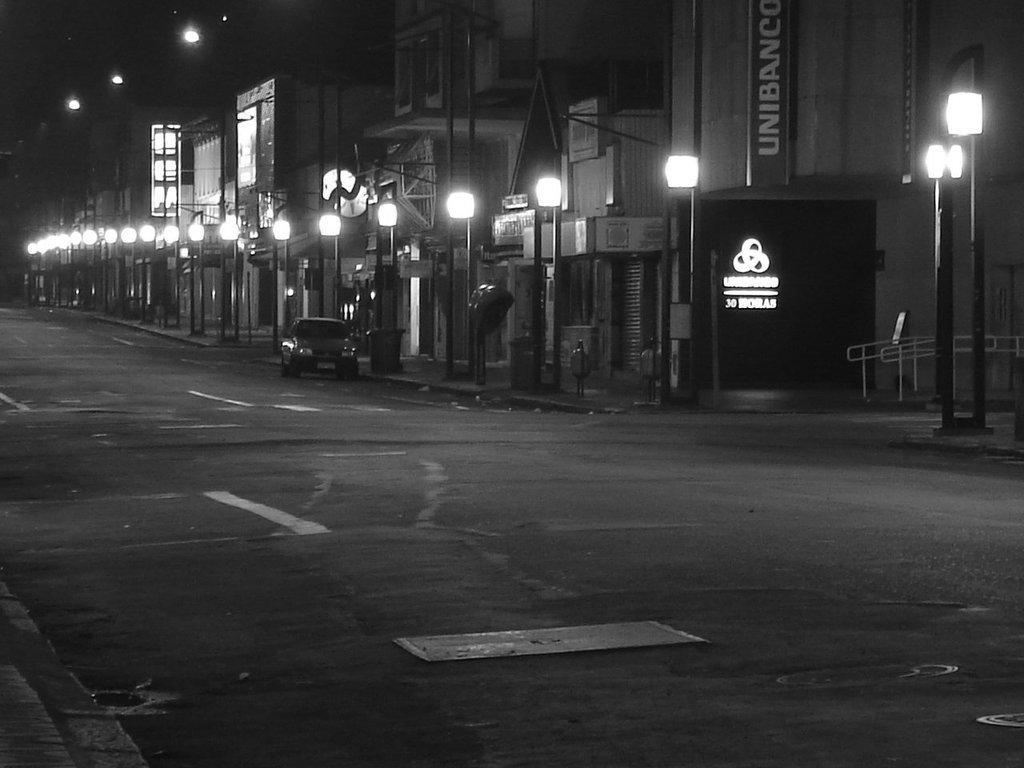Could you give a brief overview of what you see in this image? In this picture in the background there are light poles, there are buildings, boards with some text written on it and there is a car on the road, on the right side there is a railing. In the front there is a road. 